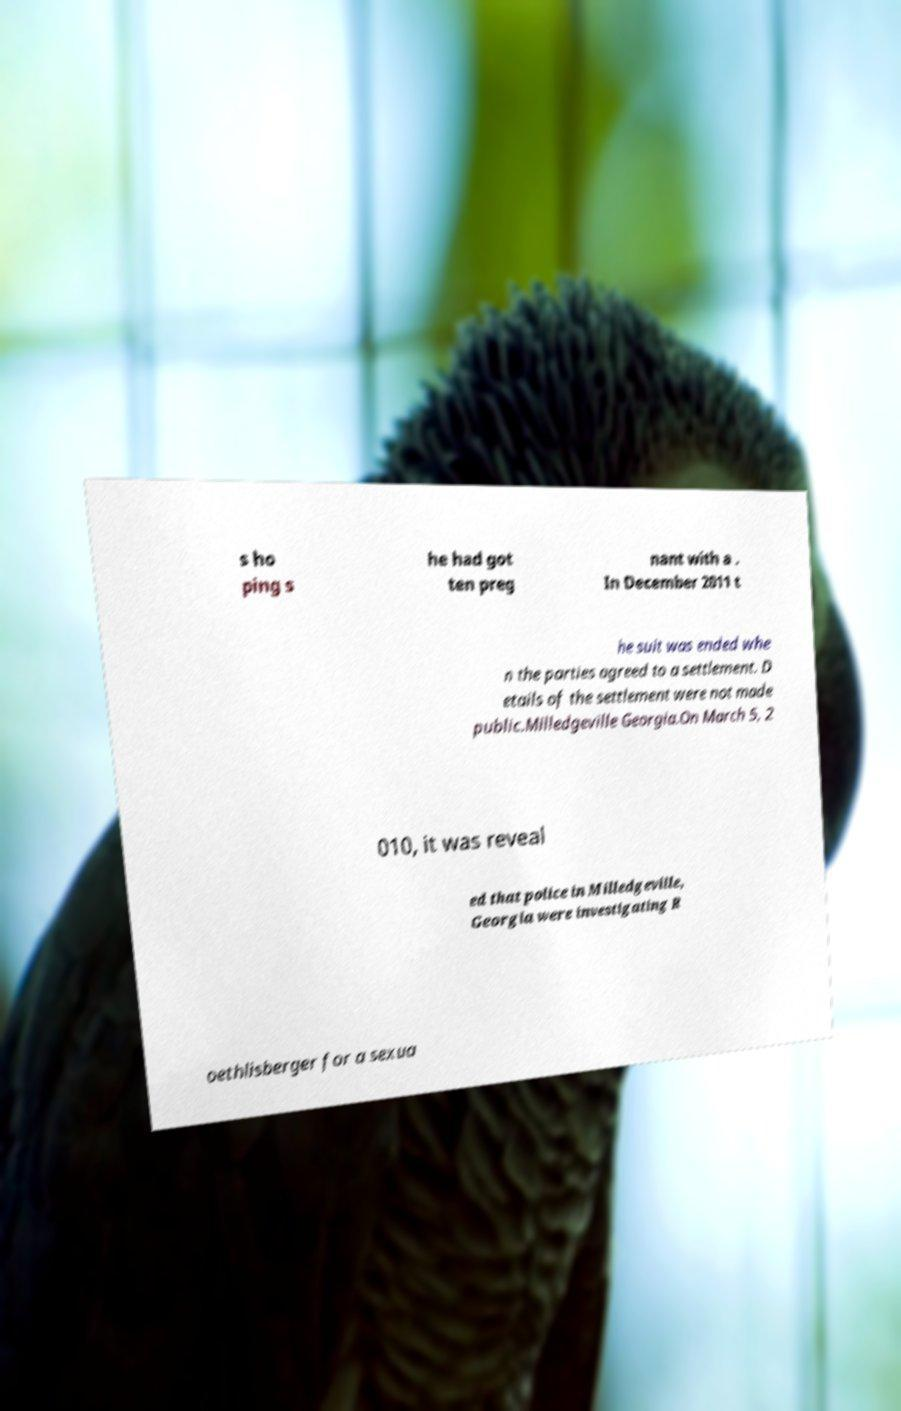Can you read and provide the text displayed in the image?This photo seems to have some interesting text. Can you extract and type it out for me? s ho ping s he had got ten preg nant with a . In December 2011 t he suit was ended whe n the parties agreed to a settlement. D etails of the settlement were not made public.Milledgeville Georgia.On March 5, 2 010, it was reveal ed that police in Milledgeville, Georgia were investigating R oethlisberger for a sexua 